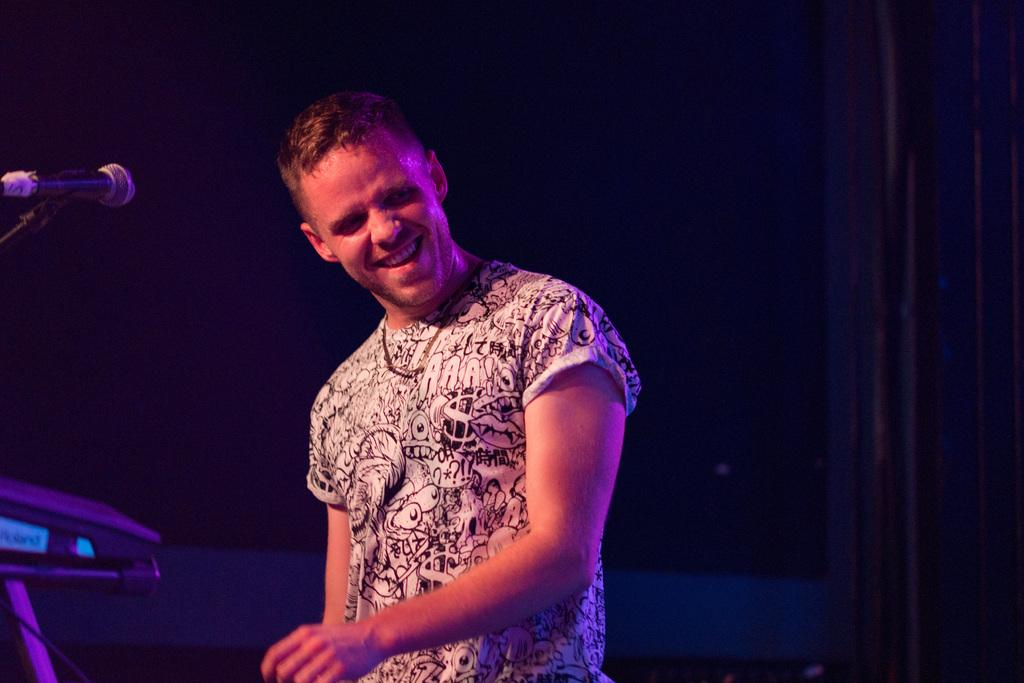Who is the main subject in the image? There is a person in the center of the image. What is the person doing in the image? The person is smiling. What equipment is visible on the left side of the image? There is a microphone and stand on the left side of the image. What can be seen in the background of the image? There is a wall in the background of the image. What type of magic trick is the person performing in the image? There is no indication of a magic trick being performed in the image; the person is simply smiling. What color is the thread used by the person in the image? There is no thread present in the image. 